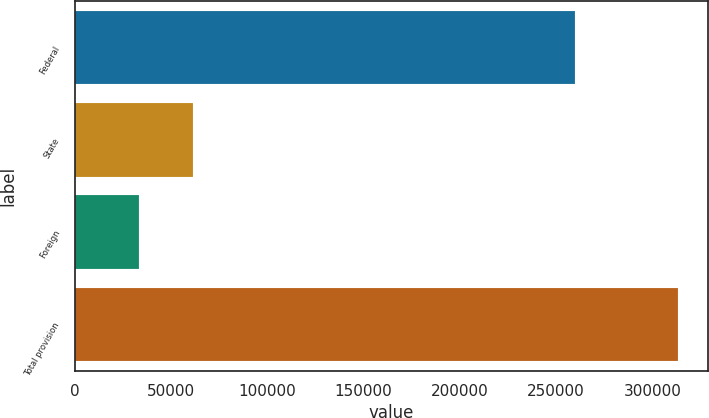<chart> <loc_0><loc_0><loc_500><loc_500><bar_chart><fcel>Federal<fcel>State<fcel>Foreign<fcel>Total provision<nl><fcel>259793<fcel>61237.7<fcel>33255<fcel>313082<nl></chart> 